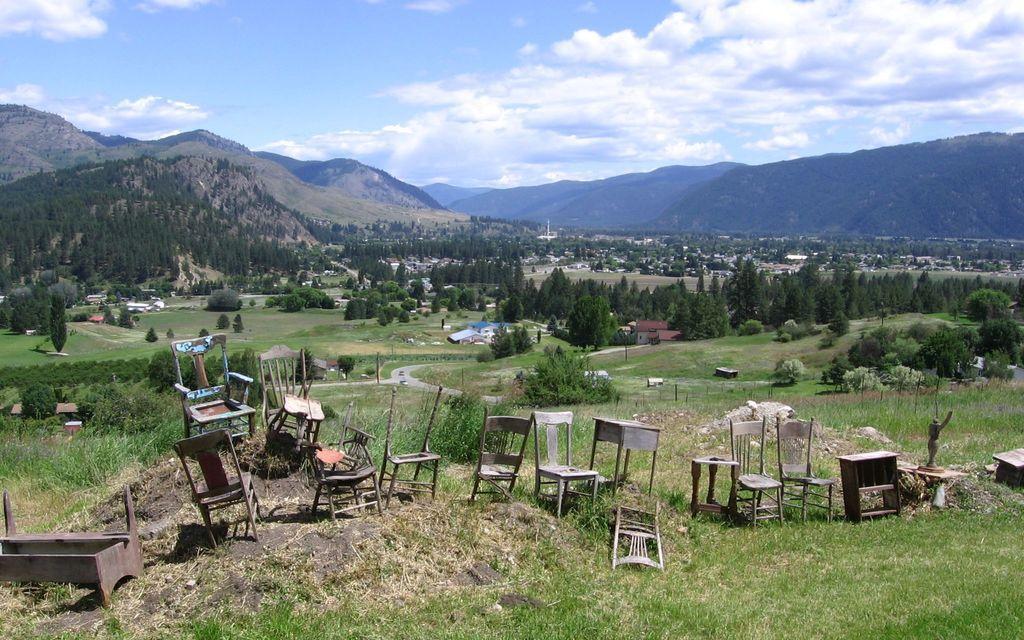Can you describe this image briefly? In this image I can see few trees, mountains, houses, poles, chairs, grass, statue, tables and few wooden objects. The sky is in blue and white color. 